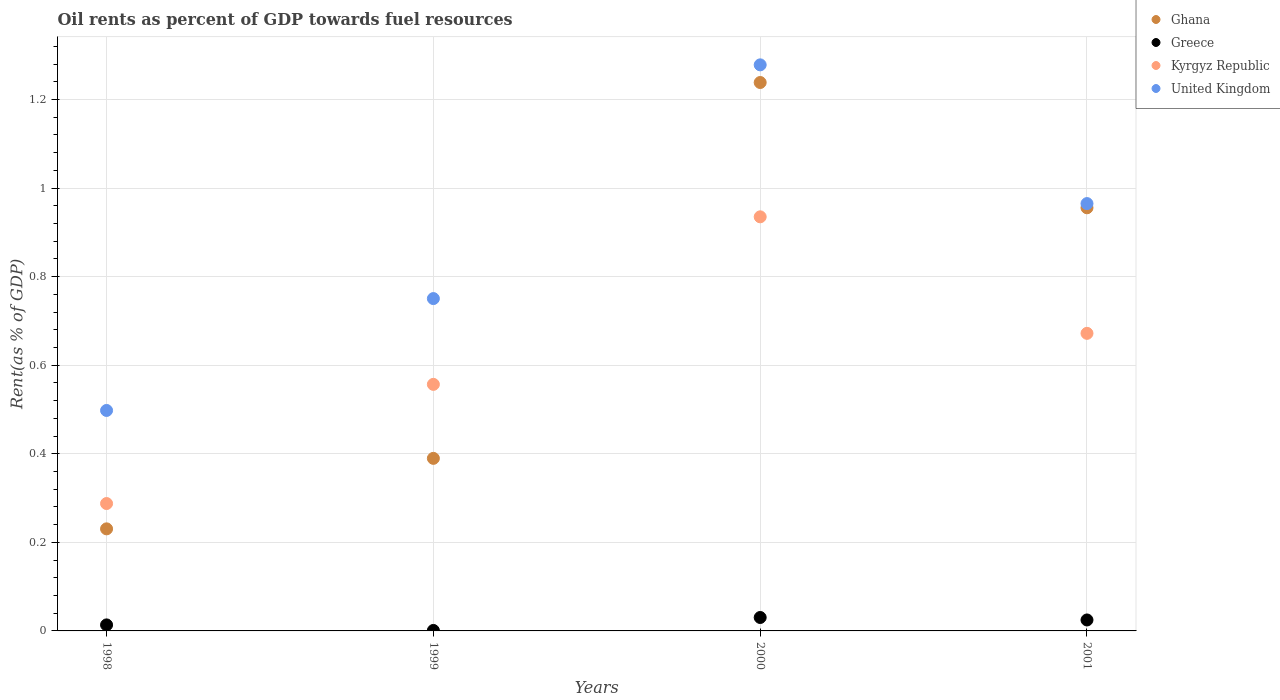How many different coloured dotlines are there?
Offer a terse response. 4. Is the number of dotlines equal to the number of legend labels?
Your response must be concise. Yes. What is the oil rent in Ghana in 2001?
Keep it short and to the point. 0.96. Across all years, what is the maximum oil rent in Greece?
Offer a very short reply. 0.03. Across all years, what is the minimum oil rent in Kyrgyz Republic?
Provide a succinct answer. 0.29. In which year was the oil rent in Ghana maximum?
Offer a very short reply. 2000. What is the total oil rent in Kyrgyz Republic in the graph?
Your answer should be compact. 2.45. What is the difference between the oil rent in Greece in 1999 and that in 2000?
Keep it short and to the point. -0.03. What is the difference between the oil rent in Kyrgyz Republic in 1999 and the oil rent in Ghana in 2001?
Provide a short and direct response. -0.4. What is the average oil rent in Kyrgyz Republic per year?
Your answer should be very brief. 0.61. In the year 1998, what is the difference between the oil rent in Greece and oil rent in Ghana?
Your answer should be compact. -0.22. In how many years, is the oil rent in Kyrgyz Republic greater than 0.68 %?
Give a very brief answer. 1. What is the ratio of the oil rent in Kyrgyz Republic in 1999 to that in 2000?
Your answer should be compact. 0.6. Is the oil rent in United Kingdom in 1998 less than that in 1999?
Keep it short and to the point. Yes. What is the difference between the highest and the second highest oil rent in Ghana?
Make the answer very short. 0.28. What is the difference between the highest and the lowest oil rent in United Kingdom?
Make the answer very short. 0.78. Is the sum of the oil rent in United Kingdom in 1998 and 1999 greater than the maximum oil rent in Greece across all years?
Your answer should be compact. Yes. How many dotlines are there?
Your answer should be very brief. 4. What is the difference between two consecutive major ticks on the Y-axis?
Provide a succinct answer. 0.2. Are the values on the major ticks of Y-axis written in scientific E-notation?
Keep it short and to the point. No. Does the graph contain grids?
Provide a short and direct response. Yes. Where does the legend appear in the graph?
Your response must be concise. Top right. How many legend labels are there?
Provide a short and direct response. 4. How are the legend labels stacked?
Offer a very short reply. Vertical. What is the title of the graph?
Keep it short and to the point. Oil rents as percent of GDP towards fuel resources. Does "Maldives" appear as one of the legend labels in the graph?
Provide a succinct answer. No. What is the label or title of the X-axis?
Your answer should be compact. Years. What is the label or title of the Y-axis?
Your answer should be very brief. Rent(as % of GDP). What is the Rent(as % of GDP) of Ghana in 1998?
Keep it short and to the point. 0.23. What is the Rent(as % of GDP) of Greece in 1998?
Your answer should be very brief. 0.01. What is the Rent(as % of GDP) of Kyrgyz Republic in 1998?
Ensure brevity in your answer.  0.29. What is the Rent(as % of GDP) in United Kingdom in 1998?
Make the answer very short. 0.5. What is the Rent(as % of GDP) in Ghana in 1999?
Offer a very short reply. 0.39. What is the Rent(as % of GDP) in Greece in 1999?
Provide a short and direct response. 0. What is the Rent(as % of GDP) of Kyrgyz Republic in 1999?
Your answer should be compact. 0.56. What is the Rent(as % of GDP) of United Kingdom in 1999?
Make the answer very short. 0.75. What is the Rent(as % of GDP) of Ghana in 2000?
Offer a terse response. 1.24. What is the Rent(as % of GDP) in Greece in 2000?
Offer a very short reply. 0.03. What is the Rent(as % of GDP) in Kyrgyz Republic in 2000?
Your answer should be very brief. 0.94. What is the Rent(as % of GDP) of United Kingdom in 2000?
Ensure brevity in your answer.  1.28. What is the Rent(as % of GDP) in Ghana in 2001?
Ensure brevity in your answer.  0.96. What is the Rent(as % of GDP) of Greece in 2001?
Keep it short and to the point. 0.02. What is the Rent(as % of GDP) of Kyrgyz Republic in 2001?
Your answer should be very brief. 0.67. What is the Rent(as % of GDP) of United Kingdom in 2001?
Give a very brief answer. 0.96. Across all years, what is the maximum Rent(as % of GDP) in Ghana?
Provide a short and direct response. 1.24. Across all years, what is the maximum Rent(as % of GDP) in Greece?
Your answer should be very brief. 0.03. Across all years, what is the maximum Rent(as % of GDP) of Kyrgyz Republic?
Make the answer very short. 0.94. Across all years, what is the maximum Rent(as % of GDP) of United Kingdom?
Keep it short and to the point. 1.28. Across all years, what is the minimum Rent(as % of GDP) in Ghana?
Provide a succinct answer. 0.23. Across all years, what is the minimum Rent(as % of GDP) in Greece?
Offer a very short reply. 0. Across all years, what is the minimum Rent(as % of GDP) in Kyrgyz Republic?
Your answer should be very brief. 0.29. Across all years, what is the minimum Rent(as % of GDP) of United Kingdom?
Provide a succinct answer. 0.5. What is the total Rent(as % of GDP) of Ghana in the graph?
Offer a very short reply. 2.81. What is the total Rent(as % of GDP) in Greece in the graph?
Keep it short and to the point. 0.07. What is the total Rent(as % of GDP) of Kyrgyz Republic in the graph?
Offer a very short reply. 2.45. What is the total Rent(as % of GDP) of United Kingdom in the graph?
Your answer should be compact. 3.49. What is the difference between the Rent(as % of GDP) of Ghana in 1998 and that in 1999?
Provide a succinct answer. -0.16. What is the difference between the Rent(as % of GDP) of Greece in 1998 and that in 1999?
Offer a terse response. 0.01. What is the difference between the Rent(as % of GDP) in Kyrgyz Republic in 1998 and that in 1999?
Make the answer very short. -0.27. What is the difference between the Rent(as % of GDP) of United Kingdom in 1998 and that in 1999?
Ensure brevity in your answer.  -0.25. What is the difference between the Rent(as % of GDP) of Ghana in 1998 and that in 2000?
Provide a short and direct response. -1.01. What is the difference between the Rent(as % of GDP) in Greece in 1998 and that in 2000?
Offer a very short reply. -0.02. What is the difference between the Rent(as % of GDP) of Kyrgyz Republic in 1998 and that in 2000?
Your response must be concise. -0.65. What is the difference between the Rent(as % of GDP) in United Kingdom in 1998 and that in 2000?
Your response must be concise. -0.78. What is the difference between the Rent(as % of GDP) in Ghana in 1998 and that in 2001?
Provide a succinct answer. -0.72. What is the difference between the Rent(as % of GDP) in Greece in 1998 and that in 2001?
Your response must be concise. -0.01. What is the difference between the Rent(as % of GDP) of Kyrgyz Republic in 1998 and that in 2001?
Make the answer very short. -0.38. What is the difference between the Rent(as % of GDP) in United Kingdom in 1998 and that in 2001?
Offer a very short reply. -0.47. What is the difference between the Rent(as % of GDP) in Ghana in 1999 and that in 2000?
Provide a short and direct response. -0.85. What is the difference between the Rent(as % of GDP) in Greece in 1999 and that in 2000?
Your answer should be compact. -0.03. What is the difference between the Rent(as % of GDP) of Kyrgyz Republic in 1999 and that in 2000?
Give a very brief answer. -0.38. What is the difference between the Rent(as % of GDP) of United Kingdom in 1999 and that in 2000?
Keep it short and to the point. -0.53. What is the difference between the Rent(as % of GDP) in Ghana in 1999 and that in 2001?
Provide a succinct answer. -0.57. What is the difference between the Rent(as % of GDP) in Greece in 1999 and that in 2001?
Make the answer very short. -0.02. What is the difference between the Rent(as % of GDP) of Kyrgyz Republic in 1999 and that in 2001?
Give a very brief answer. -0.12. What is the difference between the Rent(as % of GDP) in United Kingdom in 1999 and that in 2001?
Give a very brief answer. -0.21. What is the difference between the Rent(as % of GDP) of Ghana in 2000 and that in 2001?
Keep it short and to the point. 0.28. What is the difference between the Rent(as % of GDP) of Greece in 2000 and that in 2001?
Make the answer very short. 0.01. What is the difference between the Rent(as % of GDP) in Kyrgyz Republic in 2000 and that in 2001?
Provide a succinct answer. 0.26. What is the difference between the Rent(as % of GDP) in United Kingdom in 2000 and that in 2001?
Your answer should be compact. 0.31. What is the difference between the Rent(as % of GDP) in Ghana in 1998 and the Rent(as % of GDP) in Greece in 1999?
Offer a terse response. 0.23. What is the difference between the Rent(as % of GDP) in Ghana in 1998 and the Rent(as % of GDP) in Kyrgyz Republic in 1999?
Provide a succinct answer. -0.33. What is the difference between the Rent(as % of GDP) of Ghana in 1998 and the Rent(as % of GDP) of United Kingdom in 1999?
Make the answer very short. -0.52. What is the difference between the Rent(as % of GDP) of Greece in 1998 and the Rent(as % of GDP) of Kyrgyz Republic in 1999?
Give a very brief answer. -0.54. What is the difference between the Rent(as % of GDP) of Greece in 1998 and the Rent(as % of GDP) of United Kingdom in 1999?
Offer a terse response. -0.74. What is the difference between the Rent(as % of GDP) of Kyrgyz Republic in 1998 and the Rent(as % of GDP) of United Kingdom in 1999?
Offer a terse response. -0.46. What is the difference between the Rent(as % of GDP) of Ghana in 1998 and the Rent(as % of GDP) of Greece in 2000?
Your response must be concise. 0.2. What is the difference between the Rent(as % of GDP) in Ghana in 1998 and the Rent(as % of GDP) in Kyrgyz Republic in 2000?
Give a very brief answer. -0.7. What is the difference between the Rent(as % of GDP) of Ghana in 1998 and the Rent(as % of GDP) of United Kingdom in 2000?
Offer a very short reply. -1.05. What is the difference between the Rent(as % of GDP) in Greece in 1998 and the Rent(as % of GDP) in Kyrgyz Republic in 2000?
Provide a short and direct response. -0.92. What is the difference between the Rent(as % of GDP) of Greece in 1998 and the Rent(as % of GDP) of United Kingdom in 2000?
Your response must be concise. -1.26. What is the difference between the Rent(as % of GDP) of Kyrgyz Republic in 1998 and the Rent(as % of GDP) of United Kingdom in 2000?
Your response must be concise. -0.99. What is the difference between the Rent(as % of GDP) in Ghana in 1998 and the Rent(as % of GDP) in Greece in 2001?
Your response must be concise. 0.21. What is the difference between the Rent(as % of GDP) in Ghana in 1998 and the Rent(as % of GDP) in Kyrgyz Republic in 2001?
Your answer should be very brief. -0.44. What is the difference between the Rent(as % of GDP) in Ghana in 1998 and the Rent(as % of GDP) in United Kingdom in 2001?
Make the answer very short. -0.73. What is the difference between the Rent(as % of GDP) of Greece in 1998 and the Rent(as % of GDP) of Kyrgyz Republic in 2001?
Your answer should be very brief. -0.66. What is the difference between the Rent(as % of GDP) in Greece in 1998 and the Rent(as % of GDP) in United Kingdom in 2001?
Keep it short and to the point. -0.95. What is the difference between the Rent(as % of GDP) of Kyrgyz Republic in 1998 and the Rent(as % of GDP) of United Kingdom in 2001?
Keep it short and to the point. -0.68. What is the difference between the Rent(as % of GDP) of Ghana in 1999 and the Rent(as % of GDP) of Greece in 2000?
Offer a very short reply. 0.36. What is the difference between the Rent(as % of GDP) in Ghana in 1999 and the Rent(as % of GDP) in Kyrgyz Republic in 2000?
Provide a short and direct response. -0.55. What is the difference between the Rent(as % of GDP) in Ghana in 1999 and the Rent(as % of GDP) in United Kingdom in 2000?
Give a very brief answer. -0.89. What is the difference between the Rent(as % of GDP) of Greece in 1999 and the Rent(as % of GDP) of Kyrgyz Republic in 2000?
Offer a very short reply. -0.93. What is the difference between the Rent(as % of GDP) of Greece in 1999 and the Rent(as % of GDP) of United Kingdom in 2000?
Give a very brief answer. -1.28. What is the difference between the Rent(as % of GDP) of Kyrgyz Republic in 1999 and the Rent(as % of GDP) of United Kingdom in 2000?
Provide a short and direct response. -0.72. What is the difference between the Rent(as % of GDP) in Ghana in 1999 and the Rent(as % of GDP) in Greece in 2001?
Give a very brief answer. 0.36. What is the difference between the Rent(as % of GDP) of Ghana in 1999 and the Rent(as % of GDP) of Kyrgyz Republic in 2001?
Your answer should be compact. -0.28. What is the difference between the Rent(as % of GDP) in Ghana in 1999 and the Rent(as % of GDP) in United Kingdom in 2001?
Ensure brevity in your answer.  -0.58. What is the difference between the Rent(as % of GDP) in Greece in 1999 and the Rent(as % of GDP) in Kyrgyz Republic in 2001?
Offer a terse response. -0.67. What is the difference between the Rent(as % of GDP) of Greece in 1999 and the Rent(as % of GDP) of United Kingdom in 2001?
Keep it short and to the point. -0.96. What is the difference between the Rent(as % of GDP) in Kyrgyz Republic in 1999 and the Rent(as % of GDP) in United Kingdom in 2001?
Your answer should be very brief. -0.41. What is the difference between the Rent(as % of GDP) of Ghana in 2000 and the Rent(as % of GDP) of Greece in 2001?
Your response must be concise. 1.21. What is the difference between the Rent(as % of GDP) in Ghana in 2000 and the Rent(as % of GDP) in Kyrgyz Republic in 2001?
Your response must be concise. 0.57. What is the difference between the Rent(as % of GDP) of Ghana in 2000 and the Rent(as % of GDP) of United Kingdom in 2001?
Your response must be concise. 0.27. What is the difference between the Rent(as % of GDP) of Greece in 2000 and the Rent(as % of GDP) of Kyrgyz Republic in 2001?
Provide a succinct answer. -0.64. What is the difference between the Rent(as % of GDP) in Greece in 2000 and the Rent(as % of GDP) in United Kingdom in 2001?
Provide a short and direct response. -0.93. What is the difference between the Rent(as % of GDP) in Kyrgyz Republic in 2000 and the Rent(as % of GDP) in United Kingdom in 2001?
Make the answer very short. -0.03. What is the average Rent(as % of GDP) of Ghana per year?
Provide a short and direct response. 0.7. What is the average Rent(as % of GDP) in Greece per year?
Provide a short and direct response. 0.02. What is the average Rent(as % of GDP) of Kyrgyz Republic per year?
Offer a terse response. 0.61. What is the average Rent(as % of GDP) in United Kingdom per year?
Ensure brevity in your answer.  0.87. In the year 1998, what is the difference between the Rent(as % of GDP) of Ghana and Rent(as % of GDP) of Greece?
Give a very brief answer. 0.22. In the year 1998, what is the difference between the Rent(as % of GDP) of Ghana and Rent(as % of GDP) of Kyrgyz Republic?
Keep it short and to the point. -0.06. In the year 1998, what is the difference between the Rent(as % of GDP) in Ghana and Rent(as % of GDP) in United Kingdom?
Your response must be concise. -0.27. In the year 1998, what is the difference between the Rent(as % of GDP) of Greece and Rent(as % of GDP) of Kyrgyz Republic?
Your response must be concise. -0.27. In the year 1998, what is the difference between the Rent(as % of GDP) in Greece and Rent(as % of GDP) in United Kingdom?
Give a very brief answer. -0.48. In the year 1998, what is the difference between the Rent(as % of GDP) in Kyrgyz Republic and Rent(as % of GDP) in United Kingdom?
Offer a very short reply. -0.21. In the year 1999, what is the difference between the Rent(as % of GDP) of Ghana and Rent(as % of GDP) of Greece?
Provide a succinct answer. 0.39. In the year 1999, what is the difference between the Rent(as % of GDP) of Ghana and Rent(as % of GDP) of Kyrgyz Republic?
Give a very brief answer. -0.17. In the year 1999, what is the difference between the Rent(as % of GDP) in Ghana and Rent(as % of GDP) in United Kingdom?
Provide a succinct answer. -0.36. In the year 1999, what is the difference between the Rent(as % of GDP) in Greece and Rent(as % of GDP) in Kyrgyz Republic?
Make the answer very short. -0.56. In the year 1999, what is the difference between the Rent(as % of GDP) of Greece and Rent(as % of GDP) of United Kingdom?
Provide a succinct answer. -0.75. In the year 1999, what is the difference between the Rent(as % of GDP) in Kyrgyz Republic and Rent(as % of GDP) in United Kingdom?
Offer a very short reply. -0.19. In the year 2000, what is the difference between the Rent(as % of GDP) of Ghana and Rent(as % of GDP) of Greece?
Make the answer very short. 1.21. In the year 2000, what is the difference between the Rent(as % of GDP) of Ghana and Rent(as % of GDP) of Kyrgyz Republic?
Provide a succinct answer. 0.3. In the year 2000, what is the difference between the Rent(as % of GDP) in Ghana and Rent(as % of GDP) in United Kingdom?
Ensure brevity in your answer.  -0.04. In the year 2000, what is the difference between the Rent(as % of GDP) in Greece and Rent(as % of GDP) in Kyrgyz Republic?
Offer a very short reply. -0.9. In the year 2000, what is the difference between the Rent(as % of GDP) of Greece and Rent(as % of GDP) of United Kingdom?
Your answer should be very brief. -1.25. In the year 2000, what is the difference between the Rent(as % of GDP) in Kyrgyz Republic and Rent(as % of GDP) in United Kingdom?
Ensure brevity in your answer.  -0.34. In the year 2001, what is the difference between the Rent(as % of GDP) in Ghana and Rent(as % of GDP) in Greece?
Your answer should be very brief. 0.93. In the year 2001, what is the difference between the Rent(as % of GDP) in Ghana and Rent(as % of GDP) in Kyrgyz Republic?
Your answer should be very brief. 0.28. In the year 2001, what is the difference between the Rent(as % of GDP) of Ghana and Rent(as % of GDP) of United Kingdom?
Provide a short and direct response. -0.01. In the year 2001, what is the difference between the Rent(as % of GDP) of Greece and Rent(as % of GDP) of Kyrgyz Republic?
Offer a very short reply. -0.65. In the year 2001, what is the difference between the Rent(as % of GDP) in Greece and Rent(as % of GDP) in United Kingdom?
Your answer should be compact. -0.94. In the year 2001, what is the difference between the Rent(as % of GDP) in Kyrgyz Republic and Rent(as % of GDP) in United Kingdom?
Keep it short and to the point. -0.29. What is the ratio of the Rent(as % of GDP) of Ghana in 1998 to that in 1999?
Your answer should be compact. 0.59. What is the ratio of the Rent(as % of GDP) in Greece in 1998 to that in 1999?
Provide a short and direct response. 12.68. What is the ratio of the Rent(as % of GDP) in Kyrgyz Republic in 1998 to that in 1999?
Keep it short and to the point. 0.52. What is the ratio of the Rent(as % of GDP) in United Kingdom in 1998 to that in 1999?
Provide a succinct answer. 0.66. What is the ratio of the Rent(as % of GDP) in Ghana in 1998 to that in 2000?
Your answer should be very brief. 0.19. What is the ratio of the Rent(as % of GDP) of Greece in 1998 to that in 2000?
Provide a short and direct response. 0.45. What is the ratio of the Rent(as % of GDP) in Kyrgyz Republic in 1998 to that in 2000?
Give a very brief answer. 0.31. What is the ratio of the Rent(as % of GDP) in United Kingdom in 1998 to that in 2000?
Provide a succinct answer. 0.39. What is the ratio of the Rent(as % of GDP) in Ghana in 1998 to that in 2001?
Your answer should be very brief. 0.24. What is the ratio of the Rent(as % of GDP) of Greece in 1998 to that in 2001?
Give a very brief answer. 0.55. What is the ratio of the Rent(as % of GDP) in Kyrgyz Republic in 1998 to that in 2001?
Your answer should be compact. 0.43. What is the ratio of the Rent(as % of GDP) of United Kingdom in 1998 to that in 2001?
Ensure brevity in your answer.  0.52. What is the ratio of the Rent(as % of GDP) of Ghana in 1999 to that in 2000?
Your answer should be very brief. 0.31. What is the ratio of the Rent(as % of GDP) of Greece in 1999 to that in 2000?
Your answer should be compact. 0.04. What is the ratio of the Rent(as % of GDP) in Kyrgyz Republic in 1999 to that in 2000?
Offer a very short reply. 0.6. What is the ratio of the Rent(as % of GDP) in United Kingdom in 1999 to that in 2000?
Your response must be concise. 0.59. What is the ratio of the Rent(as % of GDP) in Ghana in 1999 to that in 2001?
Your answer should be compact. 0.41. What is the ratio of the Rent(as % of GDP) of Greece in 1999 to that in 2001?
Your answer should be very brief. 0.04. What is the ratio of the Rent(as % of GDP) of Kyrgyz Republic in 1999 to that in 2001?
Provide a succinct answer. 0.83. What is the ratio of the Rent(as % of GDP) of United Kingdom in 1999 to that in 2001?
Make the answer very short. 0.78. What is the ratio of the Rent(as % of GDP) of Ghana in 2000 to that in 2001?
Keep it short and to the point. 1.3. What is the ratio of the Rent(as % of GDP) in Greece in 2000 to that in 2001?
Provide a short and direct response. 1.23. What is the ratio of the Rent(as % of GDP) in Kyrgyz Republic in 2000 to that in 2001?
Your response must be concise. 1.39. What is the ratio of the Rent(as % of GDP) of United Kingdom in 2000 to that in 2001?
Provide a succinct answer. 1.32. What is the difference between the highest and the second highest Rent(as % of GDP) in Ghana?
Your answer should be very brief. 0.28. What is the difference between the highest and the second highest Rent(as % of GDP) of Greece?
Ensure brevity in your answer.  0.01. What is the difference between the highest and the second highest Rent(as % of GDP) of Kyrgyz Republic?
Keep it short and to the point. 0.26. What is the difference between the highest and the second highest Rent(as % of GDP) of United Kingdom?
Your answer should be very brief. 0.31. What is the difference between the highest and the lowest Rent(as % of GDP) of Ghana?
Provide a short and direct response. 1.01. What is the difference between the highest and the lowest Rent(as % of GDP) of Greece?
Provide a short and direct response. 0.03. What is the difference between the highest and the lowest Rent(as % of GDP) in Kyrgyz Republic?
Offer a very short reply. 0.65. What is the difference between the highest and the lowest Rent(as % of GDP) of United Kingdom?
Offer a very short reply. 0.78. 